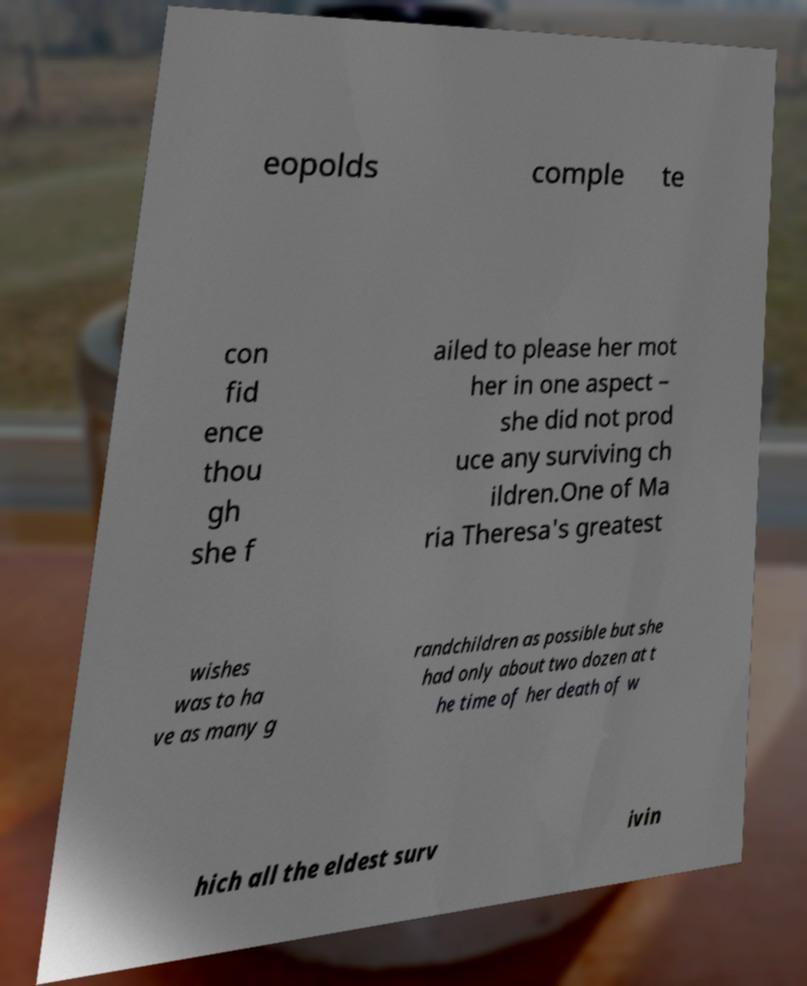I need the written content from this picture converted into text. Can you do that? eopolds comple te con fid ence thou gh she f ailed to please her mot her in one aspect – she did not prod uce any surviving ch ildren.One of Ma ria Theresa's greatest wishes was to ha ve as many g randchildren as possible but she had only about two dozen at t he time of her death of w hich all the eldest surv ivin 